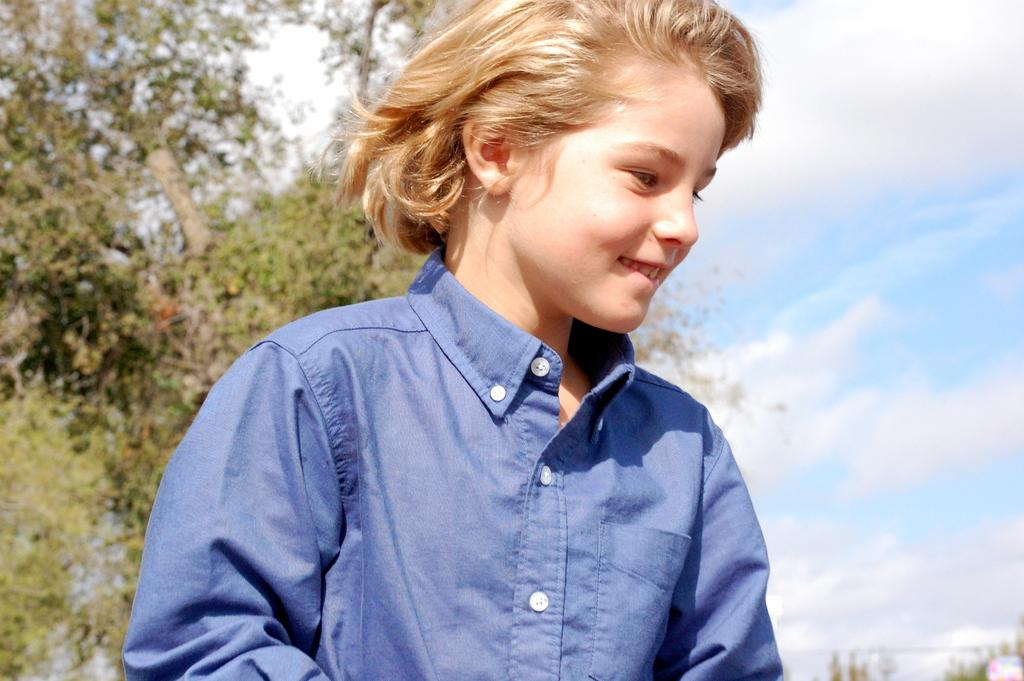Who or what is present in the image? There is a person in the image. What is the person doing in the image? The person is smiling. What can be seen in the background of the image? There are trees and the sky visible in the background of the image. What is the condition of the sky in the image? Clouds are present in the sky. How many people are lifting the crowd in the image? There is no crowd or lifting activity present in the image; it features a person smiling with trees and clouds in the background. What finger is the person pointing at in the image? There is no finger-pointing activity present in the image; the person is simply smiling. 